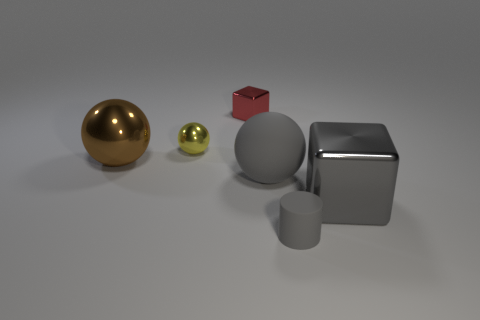Subtract all gray spheres. How many spheres are left? 2 Add 3 rubber spheres. How many objects exist? 9 Subtract all red balls. Subtract all red cylinders. How many balls are left? 3 Subtract all blocks. How many objects are left? 4 Subtract all gray rubber cylinders. Subtract all tiny blue cylinders. How many objects are left? 5 Add 5 large metallic spheres. How many large metallic spheres are left? 6 Add 5 matte balls. How many matte balls exist? 6 Subtract 0 purple balls. How many objects are left? 6 